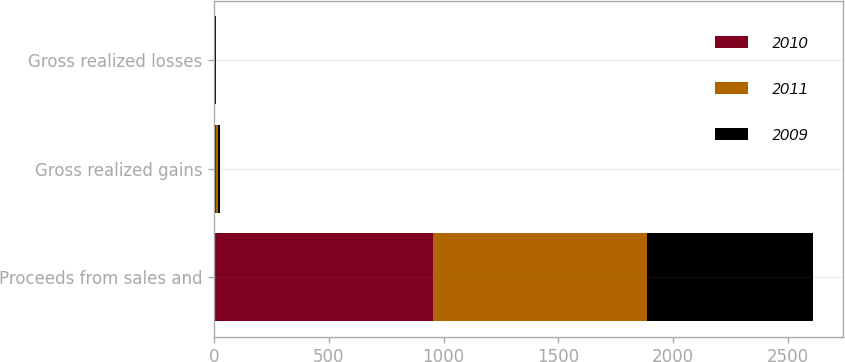Convert chart to OTSL. <chart><loc_0><loc_0><loc_500><loc_500><stacked_bar_chart><ecel><fcel>Proceeds from sales and<fcel>Gross realized gains<fcel>Gross realized losses<nl><fcel>2010<fcel>955.7<fcel>7.5<fcel>2.3<nl><fcel>2011<fcel>931<fcel>10.4<fcel>2.3<nl><fcel>2009<fcel>725<fcel>7<fcel>2.3<nl></chart> 